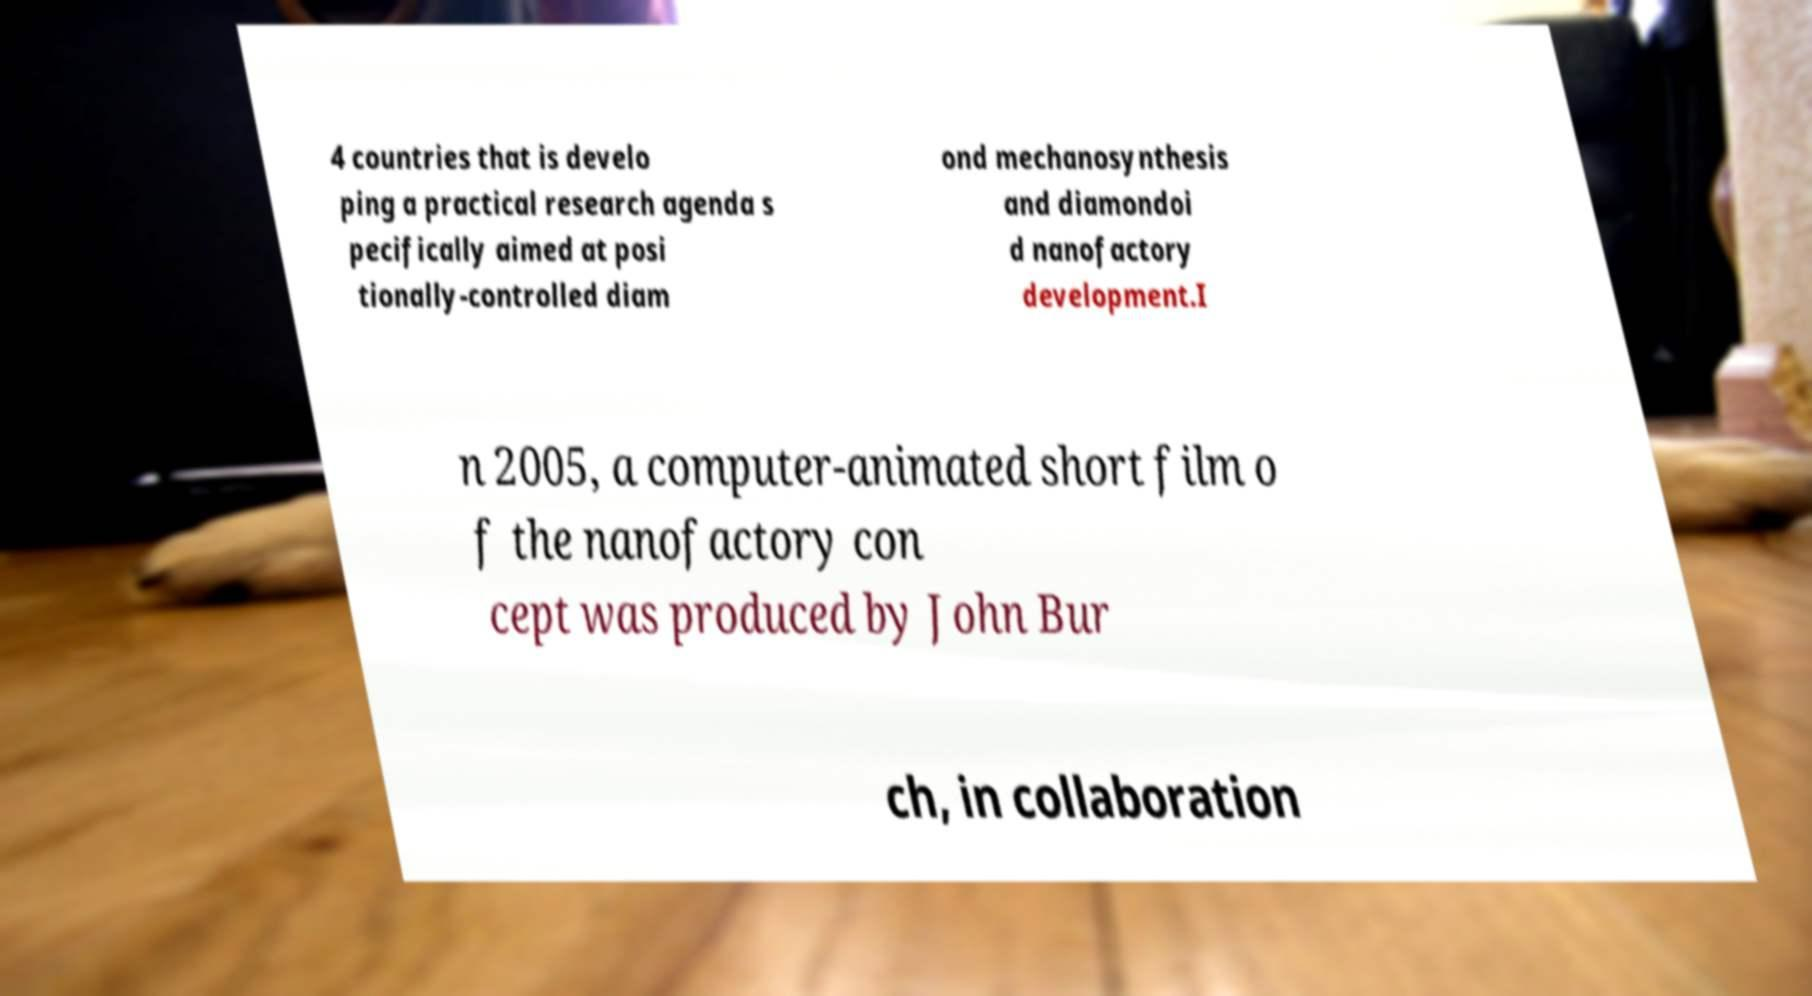For documentation purposes, I need the text within this image transcribed. Could you provide that? 4 countries that is develo ping a practical research agenda s pecifically aimed at posi tionally-controlled diam ond mechanosynthesis and diamondoi d nanofactory development.I n 2005, a computer-animated short film o f the nanofactory con cept was produced by John Bur ch, in collaboration 